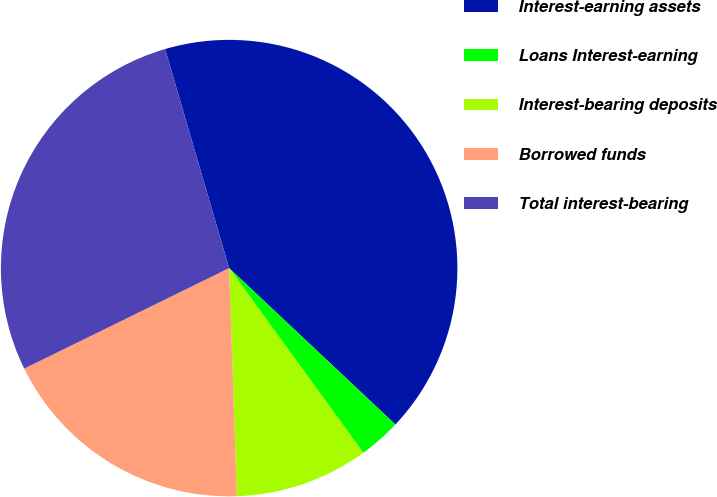Convert chart. <chart><loc_0><loc_0><loc_500><loc_500><pie_chart><fcel>Interest-earning assets<fcel>Loans Interest-earning<fcel>Interest-bearing deposits<fcel>Borrowed funds<fcel>Total interest-bearing<nl><fcel>41.54%<fcel>2.99%<fcel>9.46%<fcel>18.28%<fcel>27.73%<nl></chart> 